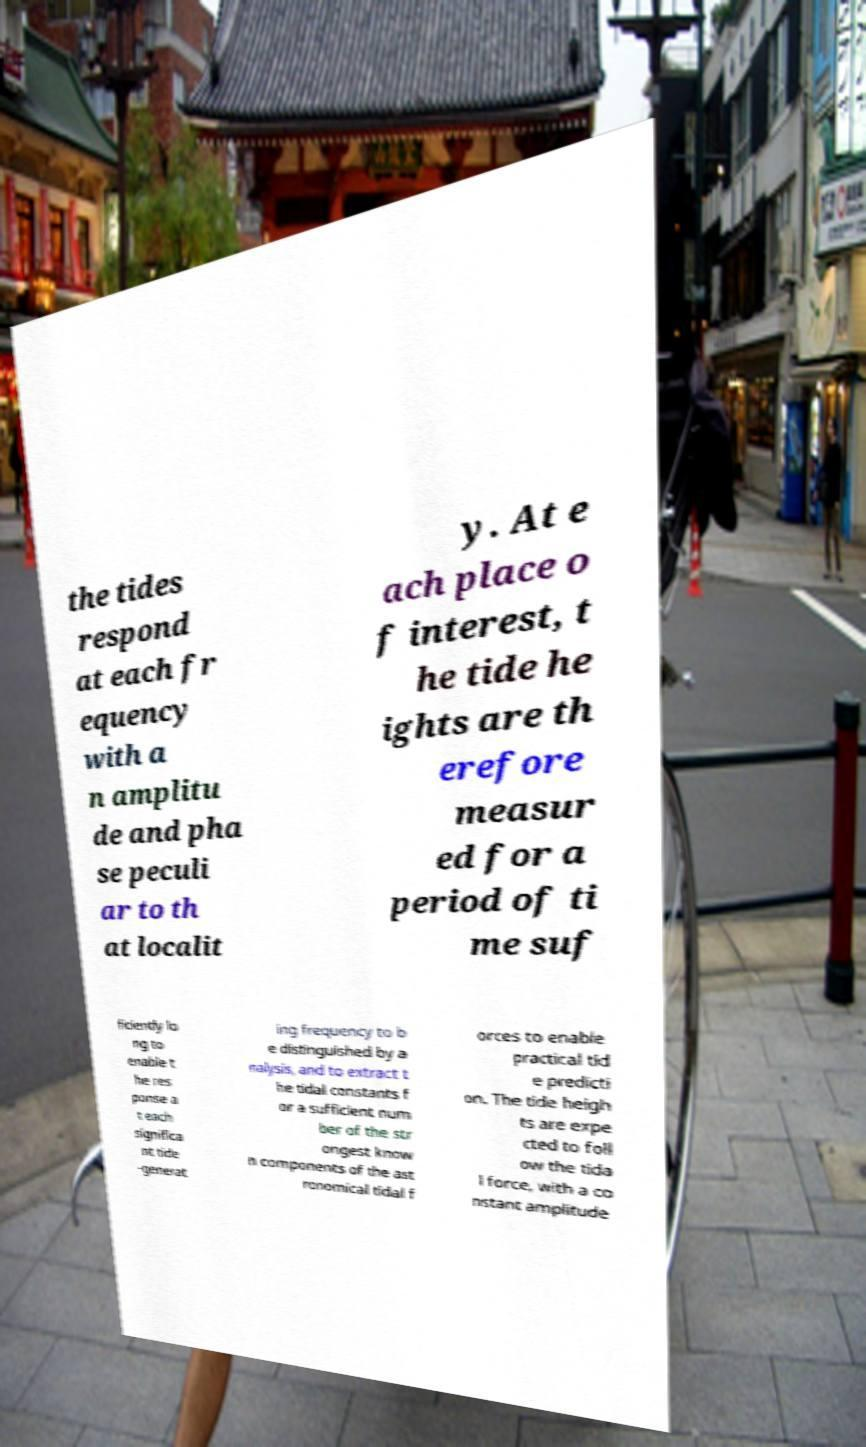I need the written content from this picture converted into text. Can you do that? the tides respond at each fr equency with a n amplitu de and pha se peculi ar to th at localit y. At e ach place o f interest, t he tide he ights are th erefore measur ed for a period of ti me suf ficiently lo ng to enable t he res ponse a t each significa nt tide -generat ing frequency to b e distinguished by a nalysis, and to extract t he tidal constants f or a sufficient num ber of the str ongest know n components of the ast ronomical tidal f orces to enable practical tid e predicti on. The tide heigh ts are expe cted to foll ow the tida l force, with a co nstant amplitude 